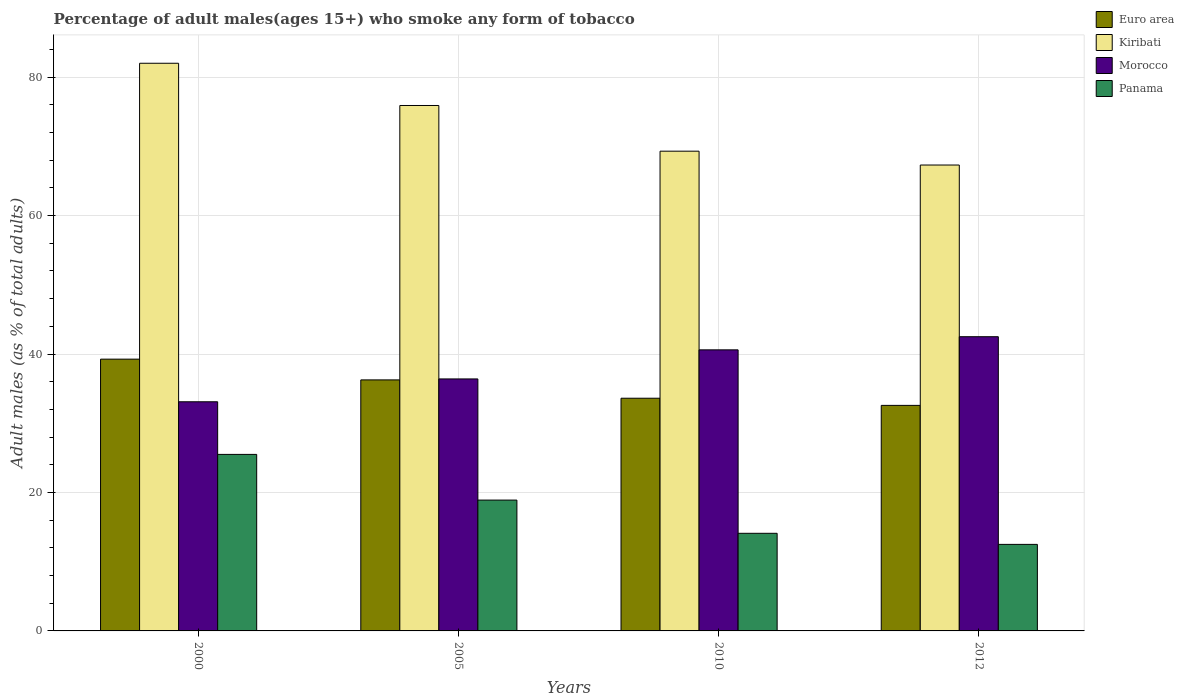How many different coloured bars are there?
Give a very brief answer. 4. How many groups of bars are there?
Provide a succinct answer. 4. How many bars are there on the 1st tick from the right?
Keep it short and to the point. 4. Across all years, what is the maximum percentage of adult males who smoke in Euro area?
Provide a succinct answer. 39.26. Across all years, what is the minimum percentage of adult males who smoke in Kiribati?
Keep it short and to the point. 67.3. In which year was the percentage of adult males who smoke in Morocco minimum?
Your answer should be very brief. 2000. What is the difference between the percentage of adult males who smoke in Morocco in 2010 and that in 2012?
Provide a short and direct response. -1.9. What is the difference between the percentage of adult males who smoke in Kiribati in 2000 and the percentage of adult males who smoke in Euro area in 2010?
Give a very brief answer. 48.39. What is the average percentage of adult males who smoke in Panama per year?
Make the answer very short. 17.75. In the year 2012, what is the difference between the percentage of adult males who smoke in Euro area and percentage of adult males who smoke in Panama?
Make the answer very short. 20.08. What is the ratio of the percentage of adult males who smoke in Morocco in 2000 to that in 2010?
Make the answer very short. 0.82. Is the percentage of adult males who smoke in Kiribati in 2000 less than that in 2010?
Keep it short and to the point. No. What is the difference between the highest and the second highest percentage of adult males who smoke in Panama?
Offer a terse response. 6.6. What is the difference between the highest and the lowest percentage of adult males who smoke in Euro area?
Offer a terse response. 6.68. In how many years, is the percentage of adult males who smoke in Euro area greater than the average percentage of adult males who smoke in Euro area taken over all years?
Give a very brief answer. 2. What does the 3rd bar from the left in 2010 represents?
Provide a succinct answer. Morocco. What does the 1st bar from the right in 2000 represents?
Your response must be concise. Panama. Is it the case that in every year, the sum of the percentage of adult males who smoke in Kiribati and percentage of adult males who smoke in Panama is greater than the percentage of adult males who smoke in Euro area?
Provide a succinct answer. Yes. Are all the bars in the graph horizontal?
Your response must be concise. No. How many years are there in the graph?
Offer a terse response. 4. Where does the legend appear in the graph?
Offer a very short reply. Top right. How many legend labels are there?
Your answer should be very brief. 4. How are the legend labels stacked?
Provide a short and direct response. Vertical. What is the title of the graph?
Make the answer very short. Percentage of adult males(ages 15+) who smoke any form of tobacco. Does "Benin" appear as one of the legend labels in the graph?
Your response must be concise. No. What is the label or title of the X-axis?
Your answer should be very brief. Years. What is the label or title of the Y-axis?
Offer a terse response. Adult males (as % of total adults). What is the Adult males (as % of total adults) of Euro area in 2000?
Your answer should be very brief. 39.26. What is the Adult males (as % of total adults) in Kiribati in 2000?
Provide a succinct answer. 82. What is the Adult males (as % of total adults) of Morocco in 2000?
Ensure brevity in your answer.  33.1. What is the Adult males (as % of total adults) of Euro area in 2005?
Offer a very short reply. 36.26. What is the Adult males (as % of total adults) in Kiribati in 2005?
Provide a short and direct response. 75.9. What is the Adult males (as % of total adults) in Morocco in 2005?
Your response must be concise. 36.4. What is the Adult males (as % of total adults) of Euro area in 2010?
Your answer should be very brief. 33.61. What is the Adult males (as % of total adults) in Kiribati in 2010?
Make the answer very short. 69.3. What is the Adult males (as % of total adults) in Morocco in 2010?
Offer a very short reply. 40.6. What is the Adult males (as % of total adults) of Euro area in 2012?
Provide a short and direct response. 32.58. What is the Adult males (as % of total adults) of Kiribati in 2012?
Offer a terse response. 67.3. What is the Adult males (as % of total adults) in Morocco in 2012?
Give a very brief answer. 42.5. What is the Adult males (as % of total adults) in Panama in 2012?
Provide a short and direct response. 12.5. Across all years, what is the maximum Adult males (as % of total adults) of Euro area?
Your answer should be very brief. 39.26. Across all years, what is the maximum Adult males (as % of total adults) in Kiribati?
Provide a short and direct response. 82. Across all years, what is the maximum Adult males (as % of total adults) in Morocco?
Your answer should be very brief. 42.5. Across all years, what is the maximum Adult males (as % of total adults) in Panama?
Give a very brief answer. 25.5. Across all years, what is the minimum Adult males (as % of total adults) of Euro area?
Ensure brevity in your answer.  32.58. Across all years, what is the minimum Adult males (as % of total adults) of Kiribati?
Make the answer very short. 67.3. Across all years, what is the minimum Adult males (as % of total adults) of Morocco?
Provide a succinct answer. 33.1. What is the total Adult males (as % of total adults) of Euro area in the graph?
Provide a short and direct response. 141.71. What is the total Adult males (as % of total adults) of Kiribati in the graph?
Offer a very short reply. 294.5. What is the total Adult males (as % of total adults) in Morocco in the graph?
Your response must be concise. 152.6. What is the difference between the Adult males (as % of total adults) of Euro area in 2000 and that in 2005?
Provide a short and direct response. 3. What is the difference between the Adult males (as % of total adults) in Kiribati in 2000 and that in 2005?
Your answer should be compact. 6.1. What is the difference between the Adult males (as % of total adults) of Morocco in 2000 and that in 2005?
Ensure brevity in your answer.  -3.3. What is the difference between the Adult males (as % of total adults) of Euro area in 2000 and that in 2010?
Provide a short and direct response. 5.64. What is the difference between the Adult males (as % of total adults) in Kiribati in 2000 and that in 2010?
Give a very brief answer. 12.7. What is the difference between the Adult males (as % of total adults) in Morocco in 2000 and that in 2010?
Keep it short and to the point. -7.5. What is the difference between the Adult males (as % of total adults) in Panama in 2000 and that in 2010?
Make the answer very short. 11.4. What is the difference between the Adult males (as % of total adults) of Euro area in 2000 and that in 2012?
Your answer should be compact. 6.68. What is the difference between the Adult males (as % of total adults) of Euro area in 2005 and that in 2010?
Provide a short and direct response. 2.65. What is the difference between the Adult males (as % of total adults) in Panama in 2005 and that in 2010?
Keep it short and to the point. 4.8. What is the difference between the Adult males (as % of total adults) of Euro area in 2005 and that in 2012?
Provide a short and direct response. 3.68. What is the difference between the Adult males (as % of total adults) in Panama in 2005 and that in 2012?
Your response must be concise. 6.4. What is the difference between the Adult males (as % of total adults) in Euro area in 2010 and that in 2012?
Offer a very short reply. 1.03. What is the difference between the Adult males (as % of total adults) in Euro area in 2000 and the Adult males (as % of total adults) in Kiribati in 2005?
Ensure brevity in your answer.  -36.64. What is the difference between the Adult males (as % of total adults) of Euro area in 2000 and the Adult males (as % of total adults) of Morocco in 2005?
Keep it short and to the point. 2.86. What is the difference between the Adult males (as % of total adults) of Euro area in 2000 and the Adult males (as % of total adults) of Panama in 2005?
Your answer should be very brief. 20.36. What is the difference between the Adult males (as % of total adults) in Kiribati in 2000 and the Adult males (as % of total adults) in Morocco in 2005?
Give a very brief answer. 45.6. What is the difference between the Adult males (as % of total adults) in Kiribati in 2000 and the Adult males (as % of total adults) in Panama in 2005?
Keep it short and to the point. 63.1. What is the difference between the Adult males (as % of total adults) in Morocco in 2000 and the Adult males (as % of total adults) in Panama in 2005?
Your answer should be very brief. 14.2. What is the difference between the Adult males (as % of total adults) in Euro area in 2000 and the Adult males (as % of total adults) in Kiribati in 2010?
Ensure brevity in your answer.  -30.04. What is the difference between the Adult males (as % of total adults) of Euro area in 2000 and the Adult males (as % of total adults) of Morocco in 2010?
Your answer should be very brief. -1.34. What is the difference between the Adult males (as % of total adults) in Euro area in 2000 and the Adult males (as % of total adults) in Panama in 2010?
Your answer should be compact. 25.16. What is the difference between the Adult males (as % of total adults) in Kiribati in 2000 and the Adult males (as % of total adults) in Morocco in 2010?
Give a very brief answer. 41.4. What is the difference between the Adult males (as % of total adults) of Kiribati in 2000 and the Adult males (as % of total adults) of Panama in 2010?
Give a very brief answer. 67.9. What is the difference between the Adult males (as % of total adults) of Morocco in 2000 and the Adult males (as % of total adults) of Panama in 2010?
Provide a succinct answer. 19. What is the difference between the Adult males (as % of total adults) of Euro area in 2000 and the Adult males (as % of total adults) of Kiribati in 2012?
Ensure brevity in your answer.  -28.04. What is the difference between the Adult males (as % of total adults) of Euro area in 2000 and the Adult males (as % of total adults) of Morocco in 2012?
Provide a short and direct response. -3.24. What is the difference between the Adult males (as % of total adults) of Euro area in 2000 and the Adult males (as % of total adults) of Panama in 2012?
Your answer should be very brief. 26.76. What is the difference between the Adult males (as % of total adults) in Kiribati in 2000 and the Adult males (as % of total adults) in Morocco in 2012?
Offer a very short reply. 39.5. What is the difference between the Adult males (as % of total adults) of Kiribati in 2000 and the Adult males (as % of total adults) of Panama in 2012?
Give a very brief answer. 69.5. What is the difference between the Adult males (as % of total adults) in Morocco in 2000 and the Adult males (as % of total adults) in Panama in 2012?
Provide a succinct answer. 20.6. What is the difference between the Adult males (as % of total adults) of Euro area in 2005 and the Adult males (as % of total adults) of Kiribati in 2010?
Offer a terse response. -33.04. What is the difference between the Adult males (as % of total adults) in Euro area in 2005 and the Adult males (as % of total adults) in Morocco in 2010?
Make the answer very short. -4.34. What is the difference between the Adult males (as % of total adults) of Euro area in 2005 and the Adult males (as % of total adults) of Panama in 2010?
Keep it short and to the point. 22.16. What is the difference between the Adult males (as % of total adults) in Kiribati in 2005 and the Adult males (as % of total adults) in Morocco in 2010?
Keep it short and to the point. 35.3. What is the difference between the Adult males (as % of total adults) of Kiribati in 2005 and the Adult males (as % of total adults) of Panama in 2010?
Offer a very short reply. 61.8. What is the difference between the Adult males (as % of total adults) of Morocco in 2005 and the Adult males (as % of total adults) of Panama in 2010?
Make the answer very short. 22.3. What is the difference between the Adult males (as % of total adults) in Euro area in 2005 and the Adult males (as % of total adults) in Kiribati in 2012?
Keep it short and to the point. -31.04. What is the difference between the Adult males (as % of total adults) in Euro area in 2005 and the Adult males (as % of total adults) in Morocco in 2012?
Provide a succinct answer. -6.24. What is the difference between the Adult males (as % of total adults) of Euro area in 2005 and the Adult males (as % of total adults) of Panama in 2012?
Provide a short and direct response. 23.76. What is the difference between the Adult males (as % of total adults) of Kiribati in 2005 and the Adult males (as % of total adults) of Morocco in 2012?
Provide a short and direct response. 33.4. What is the difference between the Adult males (as % of total adults) in Kiribati in 2005 and the Adult males (as % of total adults) in Panama in 2012?
Provide a succinct answer. 63.4. What is the difference between the Adult males (as % of total adults) of Morocco in 2005 and the Adult males (as % of total adults) of Panama in 2012?
Make the answer very short. 23.9. What is the difference between the Adult males (as % of total adults) of Euro area in 2010 and the Adult males (as % of total adults) of Kiribati in 2012?
Offer a terse response. -33.69. What is the difference between the Adult males (as % of total adults) in Euro area in 2010 and the Adult males (as % of total adults) in Morocco in 2012?
Your answer should be compact. -8.89. What is the difference between the Adult males (as % of total adults) in Euro area in 2010 and the Adult males (as % of total adults) in Panama in 2012?
Ensure brevity in your answer.  21.11. What is the difference between the Adult males (as % of total adults) in Kiribati in 2010 and the Adult males (as % of total adults) in Morocco in 2012?
Keep it short and to the point. 26.8. What is the difference between the Adult males (as % of total adults) of Kiribati in 2010 and the Adult males (as % of total adults) of Panama in 2012?
Your answer should be compact. 56.8. What is the difference between the Adult males (as % of total adults) of Morocco in 2010 and the Adult males (as % of total adults) of Panama in 2012?
Provide a short and direct response. 28.1. What is the average Adult males (as % of total adults) of Euro area per year?
Give a very brief answer. 35.43. What is the average Adult males (as % of total adults) in Kiribati per year?
Your response must be concise. 73.62. What is the average Adult males (as % of total adults) of Morocco per year?
Your answer should be compact. 38.15. What is the average Adult males (as % of total adults) in Panama per year?
Keep it short and to the point. 17.75. In the year 2000, what is the difference between the Adult males (as % of total adults) in Euro area and Adult males (as % of total adults) in Kiribati?
Your answer should be compact. -42.74. In the year 2000, what is the difference between the Adult males (as % of total adults) of Euro area and Adult males (as % of total adults) of Morocco?
Provide a short and direct response. 6.16. In the year 2000, what is the difference between the Adult males (as % of total adults) of Euro area and Adult males (as % of total adults) of Panama?
Offer a very short reply. 13.76. In the year 2000, what is the difference between the Adult males (as % of total adults) of Kiribati and Adult males (as % of total adults) of Morocco?
Offer a terse response. 48.9. In the year 2000, what is the difference between the Adult males (as % of total adults) in Kiribati and Adult males (as % of total adults) in Panama?
Ensure brevity in your answer.  56.5. In the year 2005, what is the difference between the Adult males (as % of total adults) in Euro area and Adult males (as % of total adults) in Kiribati?
Provide a short and direct response. -39.64. In the year 2005, what is the difference between the Adult males (as % of total adults) in Euro area and Adult males (as % of total adults) in Morocco?
Keep it short and to the point. -0.14. In the year 2005, what is the difference between the Adult males (as % of total adults) in Euro area and Adult males (as % of total adults) in Panama?
Make the answer very short. 17.36. In the year 2005, what is the difference between the Adult males (as % of total adults) of Kiribati and Adult males (as % of total adults) of Morocco?
Your answer should be compact. 39.5. In the year 2005, what is the difference between the Adult males (as % of total adults) of Morocco and Adult males (as % of total adults) of Panama?
Offer a very short reply. 17.5. In the year 2010, what is the difference between the Adult males (as % of total adults) in Euro area and Adult males (as % of total adults) in Kiribati?
Make the answer very short. -35.69. In the year 2010, what is the difference between the Adult males (as % of total adults) of Euro area and Adult males (as % of total adults) of Morocco?
Offer a very short reply. -6.99. In the year 2010, what is the difference between the Adult males (as % of total adults) of Euro area and Adult males (as % of total adults) of Panama?
Keep it short and to the point. 19.51. In the year 2010, what is the difference between the Adult males (as % of total adults) of Kiribati and Adult males (as % of total adults) of Morocco?
Your answer should be very brief. 28.7. In the year 2010, what is the difference between the Adult males (as % of total adults) in Kiribati and Adult males (as % of total adults) in Panama?
Your answer should be compact. 55.2. In the year 2010, what is the difference between the Adult males (as % of total adults) of Morocco and Adult males (as % of total adults) of Panama?
Make the answer very short. 26.5. In the year 2012, what is the difference between the Adult males (as % of total adults) of Euro area and Adult males (as % of total adults) of Kiribati?
Your answer should be very brief. -34.72. In the year 2012, what is the difference between the Adult males (as % of total adults) of Euro area and Adult males (as % of total adults) of Morocco?
Offer a terse response. -9.92. In the year 2012, what is the difference between the Adult males (as % of total adults) in Euro area and Adult males (as % of total adults) in Panama?
Your response must be concise. 20.08. In the year 2012, what is the difference between the Adult males (as % of total adults) in Kiribati and Adult males (as % of total adults) in Morocco?
Provide a short and direct response. 24.8. In the year 2012, what is the difference between the Adult males (as % of total adults) of Kiribati and Adult males (as % of total adults) of Panama?
Provide a short and direct response. 54.8. In the year 2012, what is the difference between the Adult males (as % of total adults) in Morocco and Adult males (as % of total adults) in Panama?
Make the answer very short. 30. What is the ratio of the Adult males (as % of total adults) of Euro area in 2000 to that in 2005?
Your answer should be very brief. 1.08. What is the ratio of the Adult males (as % of total adults) of Kiribati in 2000 to that in 2005?
Your answer should be very brief. 1.08. What is the ratio of the Adult males (as % of total adults) in Morocco in 2000 to that in 2005?
Offer a very short reply. 0.91. What is the ratio of the Adult males (as % of total adults) in Panama in 2000 to that in 2005?
Your response must be concise. 1.35. What is the ratio of the Adult males (as % of total adults) of Euro area in 2000 to that in 2010?
Provide a short and direct response. 1.17. What is the ratio of the Adult males (as % of total adults) in Kiribati in 2000 to that in 2010?
Ensure brevity in your answer.  1.18. What is the ratio of the Adult males (as % of total adults) of Morocco in 2000 to that in 2010?
Give a very brief answer. 0.82. What is the ratio of the Adult males (as % of total adults) in Panama in 2000 to that in 2010?
Give a very brief answer. 1.81. What is the ratio of the Adult males (as % of total adults) in Euro area in 2000 to that in 2012?
Provide a succinct answer. 1.21. What is the ratio of the Adult males (as % of total adults) of Kiribati in 2000 to that in 2012?
Provide a short and direct response. 1.22. What is the ratio of the Adult males (as % of total adults) of Morocco in 2000 to that in 2012?
Make the answer very short. 0.78. What is the ratio of the Adult males (as % of total adults) in Panama in 2000 to that in 2012?
Offer a very short reply. 2.04. What is the ratio of the Adult males (as % of total adults) of Euro area in 2005 to that in 2010?
Offer a very short reply. 1.08. What is the ratio of the Adult males (as % of total adults) of Kiribati in 2005 to that in 2010?
Offer a very short reply. 1.1. What is the ratio of the Adult males (as % of total adults) of Morocco in 2005 to that in 2010?
Provide a succinct answer. 0.9. What is the ratio of the Adult males (as % of total adults) of Panama in 2005 to that in 2010?
Ensure brevity in your answer.  1.34. What is the ratio of the Adult males (as % of total adults) in Euro area in 2005 to that in 2012?
Ensure brevity in your answer.  1.11. What is the ratio of the Adult males (as % of total adults) of Kiribati in 2005 to that in 2012?
Give a very brief answer. 1.13. What is the ratio of the Adult males (as % of total adults) of Morocco in 2005 to that in 2012?
Give a very brief answer. 0.86. What is the ratio of the Adult males (as % of total adults) in Panama in 2005 to that in 2012?
Keep it short and to the point. 1.51. What is the ratio of the Adult males (as % of total adults) of Euro area in 2010 to that in 2012?
Your answer should be compact. 1.03. What is the ratio of the Adult males (as % of total adults) of Kiribati in 2010 to that in 2012?
Offer a terse response. 1.03. What is the ratio of the Adult males (as % of total adults) in Morocco in 2010 to that in 2012?
Ensure brevity in your answer.  0.96. What is the ratio of the Adult males (as % of total adults) of Panama in 2010 to that in 2012?
Give a very brief answer. 1.13. What is the difference between the highest and the second highest Adult males (as % of total adults) in Euro area?
Your answer should be very brief. 3. What is the difference between the highest and the second highest Adult males (as % of total adults) of Kiribati?
Ensure brevity in your answer.  6.1. What is the difference between the highest and the lowest Adult males (as % of total adults) in Euro area?
Provide a succinct answer. 6.68. What is the difference between the highest and the lowest Adult males (as % of total adults) in Kiribati?
Provide a short and direct response. 14.7. What is the difference between the highest and the lowest Adult males (as % of total adults) of Panama?
Your answer should be very brief. 13. 